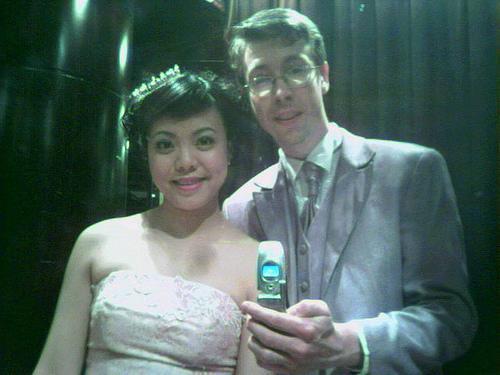How many people are pictured?
Give a very brief answer. 2. How many people are in the image?
Give a very brief answer. 2. How many people are there?
Give a very brief answer. 2. How many red cars are there?
Give a very brief answer. 0. 